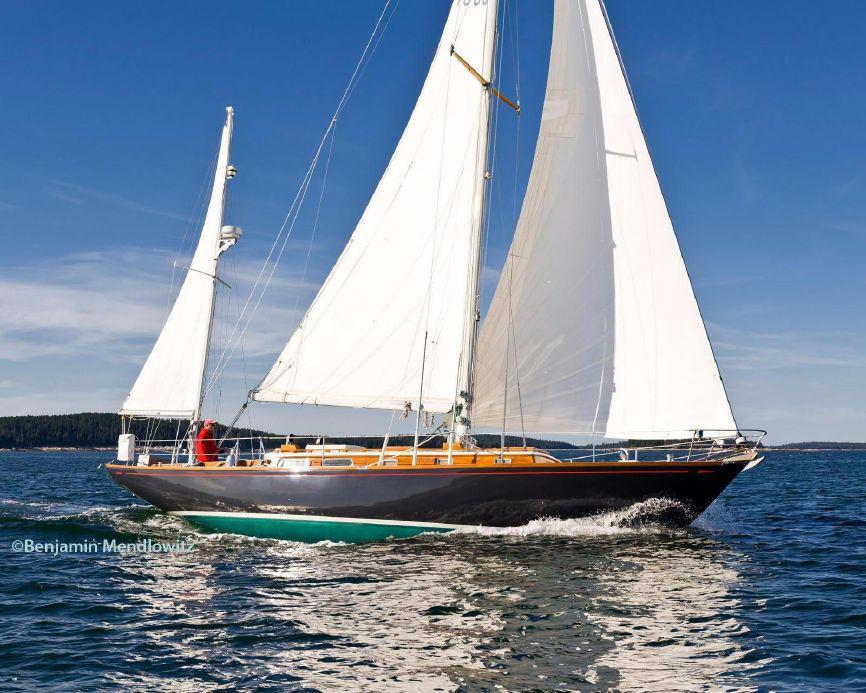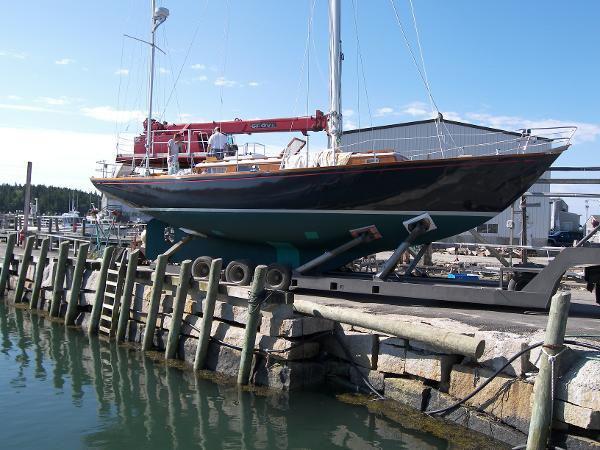The first image is the image on the left, the second image is the image on the right. Considering the images on both sides, is "A sailboat with three unfurled sails in moving through open water with a man wearing a red coat riding at the back." valid? Answer yes or no. Yes. The first image is the image on the left, the second image is the image on the right. Assess this claim about the two images: "There are three white sails up on the boat in the image on the left.". Correct or not? Answer yes or no. Yes. 